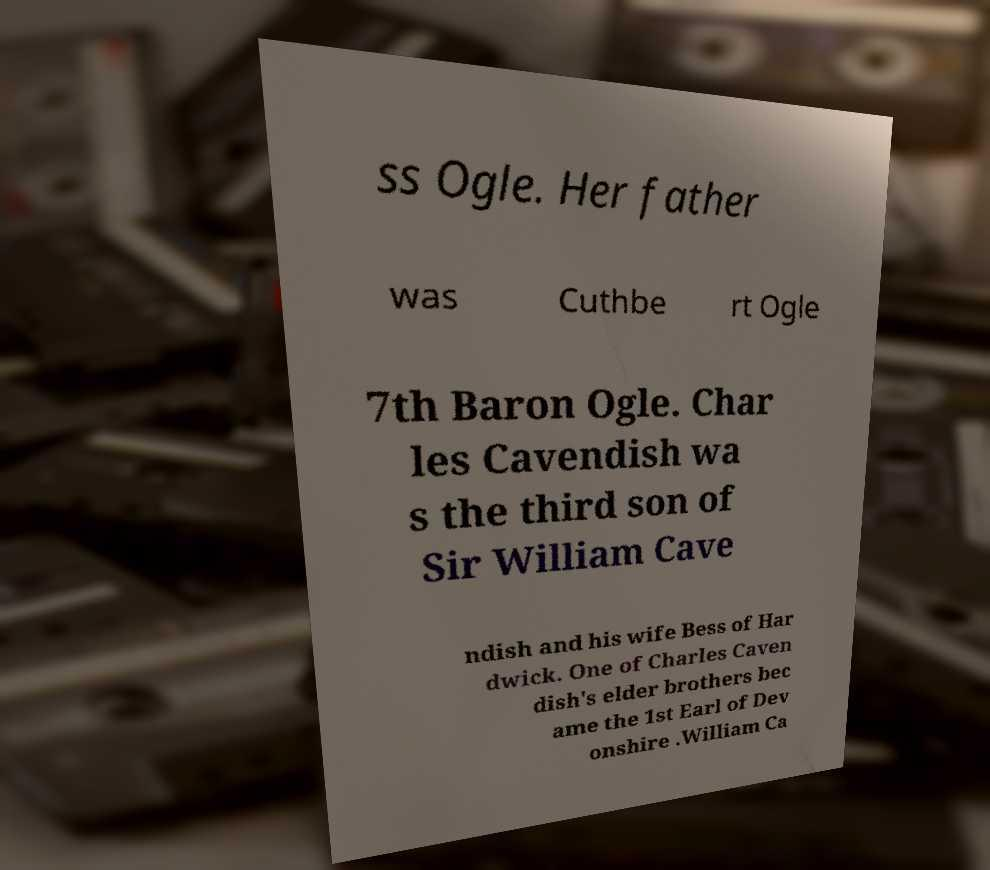For documentation purposes, I need the text within this image transcribed. Could you provide that? ss Ogle. Her father was Cuthbe rt Ogle 7th Baron Ogle. Char les Cavendish wa s the third son of Sir William Cave ndish and his wife Bess of Har dwick. One of Charles Caven dish's elder brothers bec ame the 1st Earl of Dev onshire .William Ca 